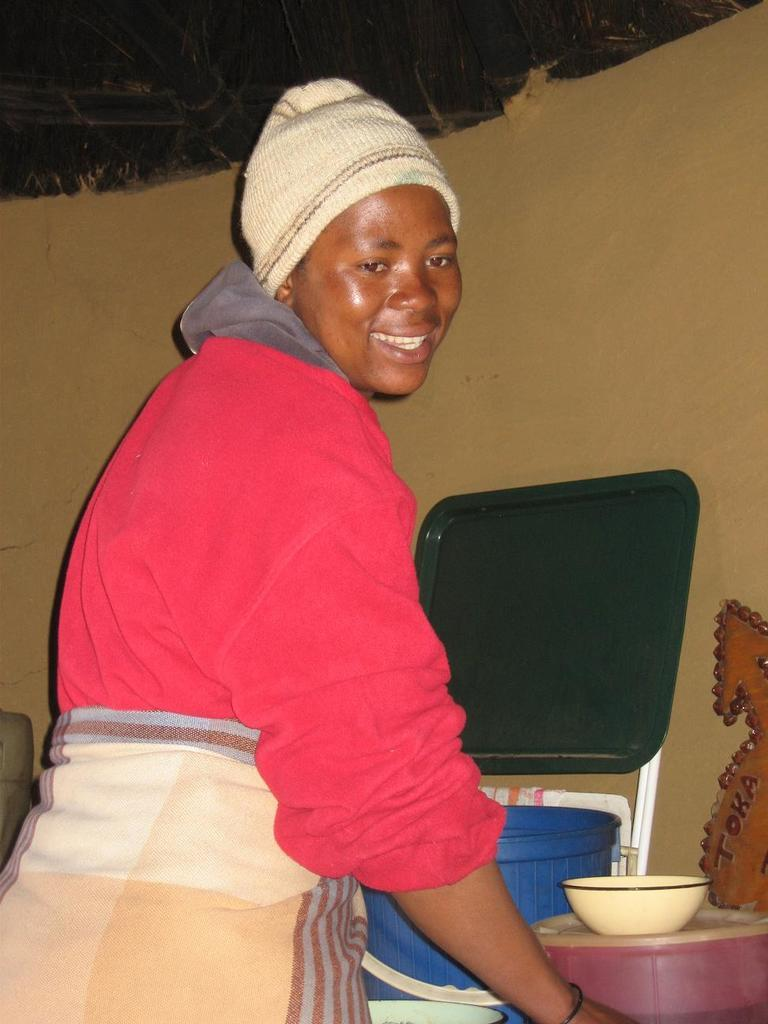What can be seen in the image related to a person? There is a person standing in the image. What is the person wearing? The person is wearing clothes and a cap. What is located near the person? There is a bowl and plastic objects in the image. What type of background can be seen in the image? There is a wall visible in the image. How many ducks are sitting on the desk in the image? There is no desk or ducks present in the image. What type of ticket can be seen in the person's hand in the image? There is no ticket visible in the person's hand in the image. 